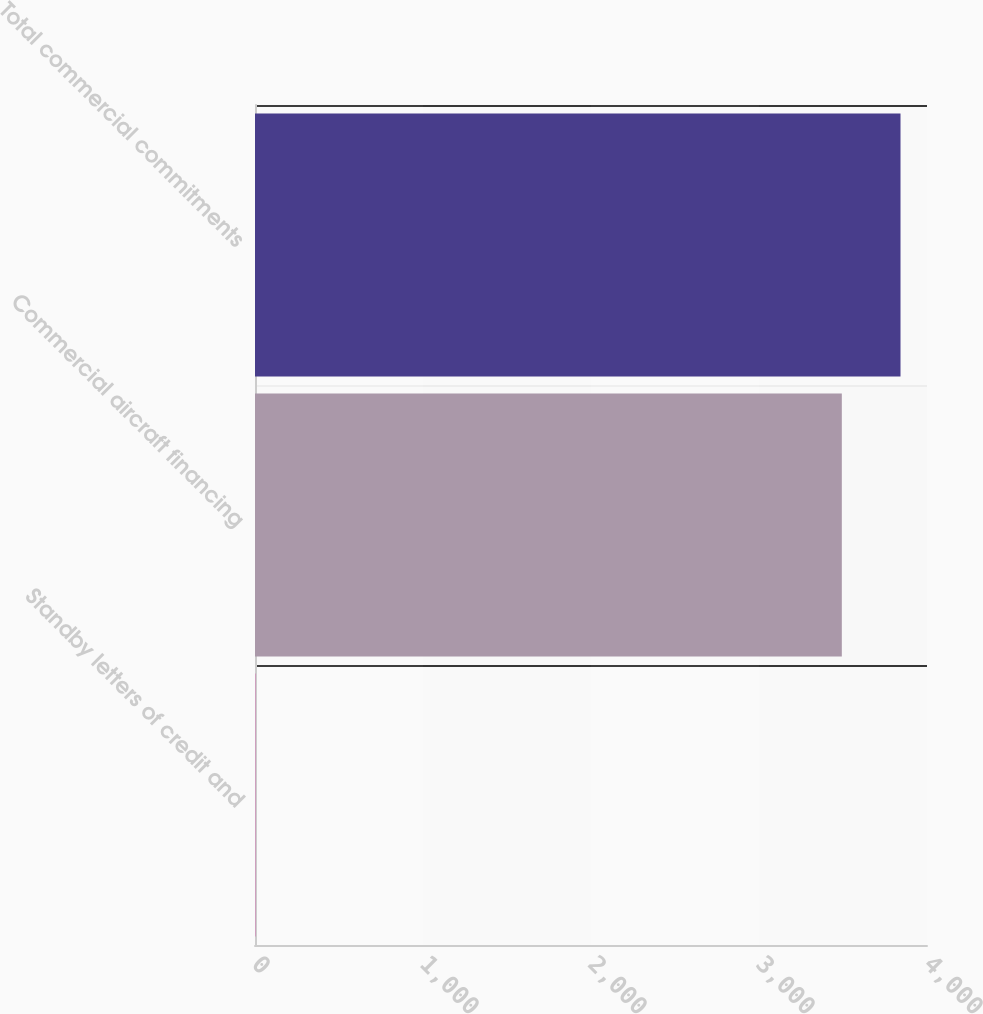Convert chart to OTSL. <chart><loc_0><loc_0><loc_500><loc_500><bar_chart><fcel>Standby letters of credit and<fcel>Commercial aircraft financing<fcel>Total commercial commitments<nl><fcel>3<fcel>3493<fcel>3842.3<nl></chart> 